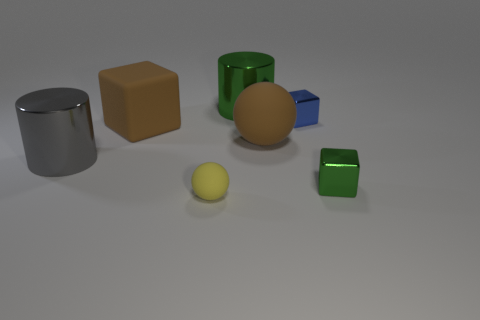Subtract all metallic cubes. How many cubes are left? 1 Add 2 red rubber cylinders. How many objects exist? 9 Subtract all blue cubes. How many cubes are left? 2 Subtract 0 purple spheres. How many objects are left? 7 Subtract all spheres. How many objects are left? 5 Subtract all cyan cylinders. Subtract all green blocks. How many cylinders are left? 2 Subtract all green metal blocks. Subtract all large rubber things. How many objects are left? 4 Add 4 gray metal cylinders. How many gray metal cylinders are left? 5 Add 2 small blue things. How many small blue things exist? 3 